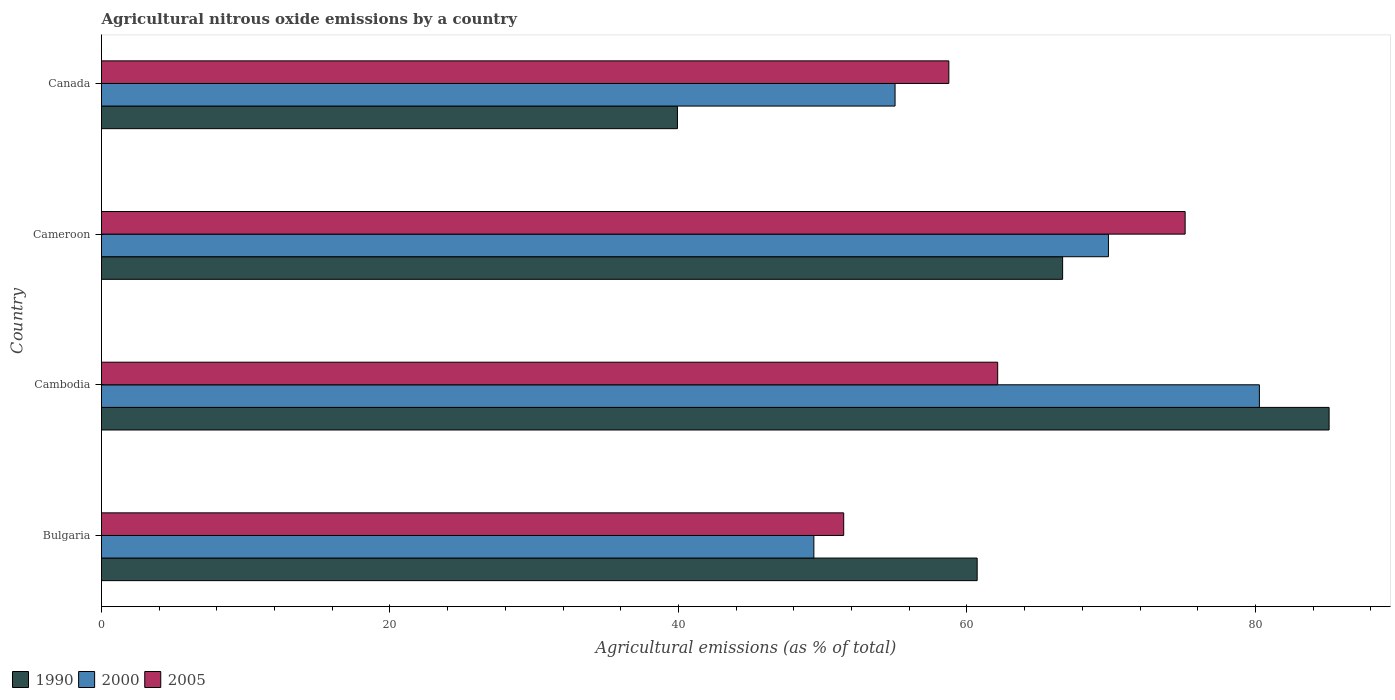How many groups of bars are there?
Your response must be concise. 4. How many bars are there on the 2nd tick from the top?
Your answer should be very brief. 3. How many bars are there on the 1st tick from the bottom?
Your response must be concise. 3. What is the label of the 4th group of bars from the top?
Provide a succinct answer. Bulgaria. What is the amount of agricultural nitrous oxide emitted in 2005 in Cameroon?
Give a very brief answer. 75.13. Across all countries, what is the maximum amount of agricultural nitrous oxide emitted in 2000?
Provide a short and direct response. 80.27. Across all countries, what is the minimum amount of agricultural nitrous oxide emitted in 2005?
Give a very brief answer. 51.46. In which country was the amount of agricultural nitrous oxide emitted in 1990 maximum?
Ensure brevity in your answer.  Cambodia. What is the total amount of agricultural nitrous oxide emitted in 2005 in the graph?
Provide a succinct answer. 247.46. What is the difference between the amount of agricultural nitrous oxide emitted in 2005 in Bulgaria and that in Cameroon?
Make the answer very short. -23.67. What is the difference between the amount of agricultural nitrous oxide emitted in 2005 in Cameroon and the amount of agricultural nitrous oxide emitted in 1990 in Cambodia?
Give a very brief answer. -9.98. What is the average amount of agricultural nitrous oxide emitted in 2000 per country?
Give a very brief answer. 63.62. What is the difference between the amount of agricultural nitrous oxide emitted in 2000 and amount of agricultural nitrous oxide emitted in 2005 in Bulgaria?
Offer a very short reply. -2.07. In how many countries, is the amount of agricultural nitrous oxide emitted in 2000 greater than 20 %?
Offer a terse response. 4. What is the ratio of the amount of agricultural nitrous oxide emitted in 2000 in Bulgaria to that in Cambodia?
Provide a succinct answer. 0.62. Is the amount of agricultural nitrous oxide emitted in 1990 in Bulgaria less than that in Cambodia?
Your answer should be very brief. Yes. Is the difference between the amount of agricultural nitrous oxide emitted in 2000 in Cambodia and Canada greater than the difference between the amount of agricultural nitrous oxide emitted in 2005 in Cambodia and Canada?
Offer a terse response. Yes. What is the difference between the highest and the second highest amount of agricultural nitrous oxide emitted in 1990?
Ensure brevity in your answer.  18.47. What is the difference between the highest and the lowest amount of agricultural nitrous oxide emitted in 1990?
Your answer should be very brief. 45.18. In how many countries, is the amount of agricultural nitrous oxide emitted in 1990 greater than the average amount of agricultural nitrous oxide emitted in 1990 taken over all countries?
Offer a very short reply. 2. Is the sum of the amount of agricultural nitrous oxide emitted in 1990 in Bulgaria and Cameroon greater than the maximum amount of agricultural nitrous oxide emitted in 2000 across all countries?
Keep it short and to the point. Yes. What does the 3rd bar from the top in Cameroon represents?
Keep it short and to the point. 1990. How many bars are there?
Make the answer very short. 12. Are all the bars in the graph horizontal?
Make the answer very short. Yes. What is the difference between two consecutive major ticks on the X-axis?
Offer a terse response. 20. Are the values on the major ticks of X-axis written in scientific E-notation?
Offer a terse response. No. Does the graph contain any zero values?
Offer a terse response. No. Does the graph contain grids?
Offer a very short reply. No. How many legend labels are there?
Give a very brief answer. 3. What is the title of the graph?
Offer a terse response. Agricultural nitrous oxide emissions by a country. What is the label or title of the X-axis?
Your answer should be compact. Agricultural emissions (as % of total). What is the Agricultural emissions (as % of total) in 1990 in Bulgaria?
Your answer should be compact. 60.71. What is the Agricultural emissions (as % of total) of 2000 in Bulgaria?
Make the answer very short. 49.39. What is the Agricultural emissions (as % of total) of 2005 in Bulgaria?
Ensure brevity in your answer.  51.46. What is the Agricultural emissions (as % of total) of 1990 in Cambodia?
Ensure brevity in your answer.  85.11. What is the Agricultural emissions (as % of total) in 2000 in Cambodia?
Offer a very short reply. 80.27. What is the Agricultural emissions (as % of total) of 2005 in Cambodia?
Your answer should be very brief. 62.13. What is the Agricultural emissions (as % of total) of 1990 in Cameroon?
Offer a very short reply. 66.63. What is the Agricultural emissions (as % of total) in 2000 in Cameroon?
Your answer should be compact. 69.81. What is the Agricultural emissions (as % of total) of 2005 in Cameroon?
Provide a succinct answer. 75.13. What is the Agricultural emissions (as % of total) of 1990 in Canada?
Offer a very short reply. 39.93. What is the Agricultural emissions (as % of total) of 2000 in Canada?
Ensure brevity in your answer.  55.02. What is the Agricultural emissions (as % of total) of 2005 in Canada?
Provide a short and direct response. 58.75. Across all countries, what is the maximum Agricultural emissions (as % of total) of 1990?
Keep it short and to the point. 85.11. Across all countries, what is the maximum Agricultural emissions (as % of total) in 2000?
Provide a succinct answer. 80.27. Across all countries, what is the maximum Agricultural emissions (as % of total) in 2005?
Keep it short and to the point. 75.13. Across all countries, what is the minimum Agricultural emissions (as % of total) of 1990?
Offer a very short reply. 39.93. Across all countries, what is the minimum Agricultural emissions (as % of total) in 2000?
Provide a succinct answer. 49.39. Across all countries, what is the minimum Agricultural emissions (as % of total) in 2005?
Provide a short and direct response. 51.46. What is the total Agricultural emissions (as % of total) in 1990 in the graph?
Ensure brevity in your answer.  252.38. What is the total Agricultural emissions (as % of total) of 2000 in the graph?
Offer a terse response. 254.49. What is the total Agricultural emissions (as % of total) in 2005 in the graph?
Offer a terse response. 247.46. What is the difference between the Agricultural emissions (as % of total) in 1990 in Bulgaria and that in Cambodia?
Provide a succinct answer. -24.4. What is the difference between the Agricultural emissions (as % of total) of 2000 in Bulgaria and that in Cambodia?
Your answer should be very brief. -30.89. What is the difference between the Agricultural emissions (as % of total) of 2005 in Bulgaria and that in Cambodia?
Ensure brevity in your answer.  -10.67. What is the difference between the Agricultural emissions (as % of total) of 1990 in Bulgaria and that in Cameroon?
Offer a very short reply. -5.93. What is the difference between the Agricultural emissions (as % of total) in 2000 in Bulgaria and that in Cameroon?
Offer a very short reply. -20.42. What is the difference between the Agricultural emissions (as % of total) in 2005 in Bulgaria and that in Cameroon?
Provide a succinct answer. -23.67. What is the difference between the Agricultural emissions (as % of total) in 1990 in Bulgaria and that in Canada?
Your response must be concise. 20.78. What is the difference between the Agricultural emissions (as % of total) in 2000 in Bulgaria and that in Canada?
Provide a succinct answer. -5.63. What is the difference between the Agricultural emissions (as % of total) of 2005 in Bulgaria and that in Canada?
Your response must be concise. -7.29. What is the difference between the Agricultural emissions (as % of total) in 1990 in Cambodia and that in Cameroon?
Offer a terse response. 18.47. What is the difference between the Agricultural emissions (as % of total) of 2000 in Cambodia and that in Cameroon?
Provide a short and direct response. 10.47. What is the difference between the Agricultural emissions (as % of total) in 2005 in Cambodia and that in Cameroon?
Your answer should be compact. -13. What is the difference between the Agricultural emissions (as % of total) of 1990 in Cambodia and that in Canada?
Your response must be concise. 45.18. What is the difference between the Agricultural emissions (as % of total) in 2000 in Cambodia and that in Canada?
Your answer should be very brief. 25.26. What is the difference between the Agricultural emissions (as % of total) of 2005 in Cambodia and that in Canada?
Offer a terse response. 3.39. What is the difference between the Agricultural emissions (as % of total) in 1990 in Cameroon and that in Canada?
Make the answer very short. 26.7. What is the difference between the Agricultural emissions (as % of total) in 2000 in Cameroon and that in Canada?
Your response must be concise. 14.79. What is the difference between the Agricultural emissions (as % of total) of 2005 in Cameroon and that in Canada?
Make the answer very short. 16.38. What is the difference between the Agricultural emissions (as % of total) of 1990 in Bulgaria and the Agricultural emissions (as % of total) of 2000 in Cambodia?
Keep it short and to the point. -19.57. What is the difference between the Agricultural emissions (as % of total) in 1990 in Bulgaria and the Agricultural emissions (as % of total) in 2005 in Cambodia?
Your answer should be very brief. -1.42. What is the difference between the Agricultural emissions (as % of total) of 2000 in Bulgaria and the Agricultural emissions (as % of total) of 2005 in Cambodia?
Keep it short and to the point. -12.74. What is the difference between the Agricultural emissions (as % of total) in 1990 in Bulgaria and the Agricultural emissions (as % of total) in 2000 in Cameroon?
Offer a very short reply. -9.1. What is the difference between the Agricultural emissions (as % of total) in 1990 in Bulgaria and the Agricultural emissions (as % of total) in 2005 in Cameroon?
Your answer should be compact. -14.42. What is the difference between the Agricultural emissions (as % of total) in 2000 in Bulgaria and the Agricultural emissions (as % of total) in 2005 in Cameroon?
Keep it short and to the point. -25.74. What is the difference between the Agricultural emissions (as % of total) in 1990 in Bulgaria and the Agricultural emissions (as % of total) in 2000 in Canada?
Provide a short and direct response. 5.69. What is the difference between the Agricultural emissions (as % of total) of 1990 in Bulgaria and the Agricultural emissions (as % of total) of 2005 in Canada?
Offer a terse response. 1.96. What is the difference between the Agricultural emissions (as % of total) of 2000 in Bulgaria and the Agricultural emissions (as % of total) of 2005 in Canada?
Give a very brief answer. -9.36. What is the difference between the Agricultural emissions (as % of total) of 1990 in Cambodia and the Agricultural emissions (as % of total) of 2000 in Cameroon?
Provide a succinct answer. 15.3. What is the difference between the Agricultural emissions (as % of total) of 1990 in Cambodia and the Agricultural emissions (as % of total) of 2005 in Cameroon?
Offer a terse response. 9.98. What is the difference between the Agricultural emissions (as % of total) of 2000 in Cambodia and the Agricultural emissions (as % of total) of 2005 in Cameroon?
Offer a terse response. 5.15. What is the difference between the Agricultural emissions (as % of total) of 1990 in Cambodia and the Agricultural emissions (as % of total) of 2000 in Canada?
Ensure brevity in your answer.  30.09. What is the difference between the Agricultural emissions (as % of total) of 1990 in Cambodia and the Agricultural emissions (as % of total) of 2005 in Canada?
Give a very brief answer. 26.36. What is the difference between the Agricultural emissions (as % of total) of 2000 in Cambodia and the Agricultural emissions (as % of total) of 2005 in Canada?
Give a very brief answer. 21.53. What is the difference between the Agricultural emissions (as % of total) in 1990 in Cameroon and the Agricultural emissions (as % of total) in 2000 in Canada?
Offer a terse response. 11.62. What is the difference between the Agricultural emissions (as % of total) of 1990 in Cameroon and the Agricultural emissions (as % of total) of 2005 in Canada?
Your response must be concise. 7.89. What is the difference between the Agricultural emissions (as % of total) in 2000 in Cameroon and the Agricultural emissions (as % of total) in 2005 in Canada?
Make the answer very short. 11.06. What is the average Agricultural emissions (as % of total) in 1990 per country?
Your answer should be very brief. 63.09. What is the average Agricultural emissions (as % of total) in 2000 per country?
Offer a terse response. 63.62. What is the average Agricultural emissions (as % of total) of 2005 per country?
Keep it short and to the point. 61.87. What is the difference between the Agricultural emissions (as % of total) in 1990 and Agricultural emissions (as % of total) in 2000 in Bulgaria?
Offer a very short reply. 11.32. What is the difference between the Agricultural emissions (as % of total) in 1990 and Agricultural emissions (as % of total) in 2005 in Bulgaria?
Offer a very short reply. 9.25. What is the difference between the Agricultural emissions (as % of total) in 2000 and Agricultural emissions (as % of total) in 2005 in Bulgaria?
Keep it short and to the point. -2.07. What is the difference between the Agricultural emissions (as % of total) in 1990 and Agricultural emissions (as % of total) in 2000 in Cambodia?
Provide a succinct answer. 4.83. What is the difference between the Agricultural emissions (as % of total) in 1990 and Agricultural emissions (as % of total) in 2005 in Cambodia?
Your answer should be compact. 22.98. What is the difference between the Agricultural emissions (as % of total) of 2000 and Agricultural emissions (as % of total) of 2005 in Cambodia?
Your response must be concise. 18.14. What is the difference between the Agricultural emissions (as % of total) of 1990 and Agricultural emissions (as % of total) of 2000 in Cameroon?
Provide a short and direct response. -3.18. What is the difference between the Agricultural emissions (as % of total) of 1990 and Agricultural emissions (as % of total) of 2005 in Cameroon?
Give a very brief answer. -8.49. What is the difference between the Agricultural emissions (as % of total) in 2000 and Agricultural emissions (as % of total) in 2005 in Cameroon?
Your answer should be compact. -5.32. What is the difference between the Agricultural emissions (as % of total) of 1990 and Agricultural emissions (as % of total) of 2000 in Canada?
Provide a succinct answer. -15.09. What is the difference between the Agricultural emissions (as % of total) in 1990 and Agricultural emissions (as % of total) in 2005 in Canada?
Your response must be concise. -18.82. What is the difference between the Agricultural emissions (as % of total) in 2000 and Agricultural emissions (as % of total) in 2005 in Canada?
Your response must be concise. -3.73. What is the ratio of the Agricultural emissions (as % of total) in 1990 in Bulgaria to that in Cambodia?
Your answer should be very brief. 0.71. What is the ratio of the Agricultural emissions (as % of total) in 2000 in Bulgaria to that in Cambodia?
Your answer should be compact. 0.62. What is the ratio of the Agricultural emissions (as % of total) in 2005 in Bulgaria to that in Cambodia?
Keep it short and to the point. 0.83. What is the ratio of the Agricultural emissions (as % of total) in 1990 in Bulgaria to that in Cameroon?
Your answer should be compact. 0.91. What is the ratio of the Agricultural emissions (as % of total) of 2000 in Bulgaria to that in Cameroon?
Your answer should be compact. 0.71. What is the ratio of the Agricultural emissions (as % of total) in 2005 in Bulgaria to that in Cameroon?
Keep it short and to the point. 0.68. What is the ratio of the Agricultural emissions (as % of total) of 1990 in Bulgaria to that in Canada?
Your answer should be compact. 1.52. What is the ratio of the Agricultural emissions (as % of total) in 2000 in Bulgaria to that in Canada?
Offer a very short reply. 0.9. What is the ratio of the Agricultural emissions (as % of total) in 2005 in Bulgaria to that in Canada?
Provide a short and direct response. 0.88. What is the ratio of the Agricultural emissions (as % of total) of 1990 in Cambodia to that in Cameroon?
Your answer should be very brief. 1.28. What is the ratio of the Agricultural emissions (as % of total) in 2000 in Cambodia to that in Cameroon?
Provide a succinct answer. 1.15. What is the ratio of the Agricultural emissions (as % of total) in 2005 in Cambodia to that in Cameroon?
Provide a short and direct response. 0.83. What is the ratio of the Agricultural emissions (as % of total) of 1990 in Cambodia to that in Canada?
Your response must be concise. 2.13. What is the ratio of the Agricultural emissions (as % of total) in 2000 in Cambodia to that in Canada?
Provide a succinct answer. 1.46. What is the ratio of the Agricultural emissions (as % of total) of 2005 in Cambodia to that in Canada?
Your answer should be very brief. 1.06. What is the ratio of the Agricultural emissions (as % of total) of 1990 in Cameroon to that in Canada?
Your answer should be very brief. 1.67. What is the ratio of the Agricultural emissions (as % of total) in 2000 in Cameroon to that in Canada?
Your response must be concise. 1.27. What is the ratio of the Agricultural emissions (as % of total) of 2005 in Cameroon to that in Canada?
Ensure brevity in your answer.  1.28. What is the difference between the highest and the second highest Agricultural emissions (as % of total) of 1990?
Give a very brief answer. 18.47. What is the difference between the highest and the second highest Agricultural emissions (as % of total) of 2000?
Your answer should be very brief. 10.47. What is the difference between the highest and the second highest Agricultural emissions (as % of total) in 2005?
Provide a succinct answer. 13. What is the difference between the highest and the lowest Agricultural emissions (as % of total) in 1990?
Ensure brevity in your answer.  45.18. What is the difference between the highest and the lowest Agricultural emissions (as % of total) in 2000?
Provide a succinct answer. 30.89. What is the difference between the highest and the lowest Agricultural emissions (as % of total) of 2005?
Provide a short and direct response. 23.67. 